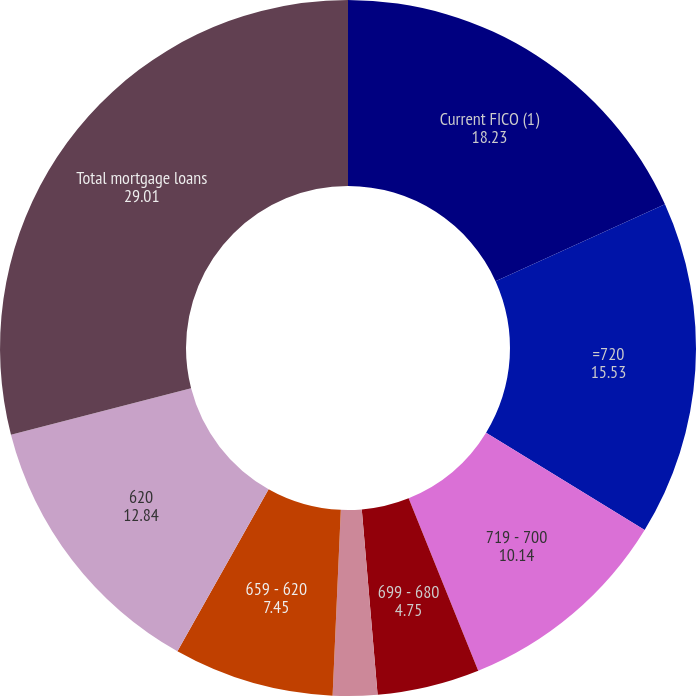Convert chart. <chart><loc_0><loc_0><loc_500><loc_500><pie_chart><fcel>Current FICO (1)<fcel>=720<fcel>719 - 700<fcel>699 - 680<fcel>679 - 660<fcel>659 - 620<fcel>620<fcel>Total mortgage loans<nl><fcel>18.23%<fcel>15.53%<fcel>10.14%<fcel>4.75%<fcel>2.06%<fcel>7.45%<fcel>12.84%<fcel>29.01%<nl></chart> 